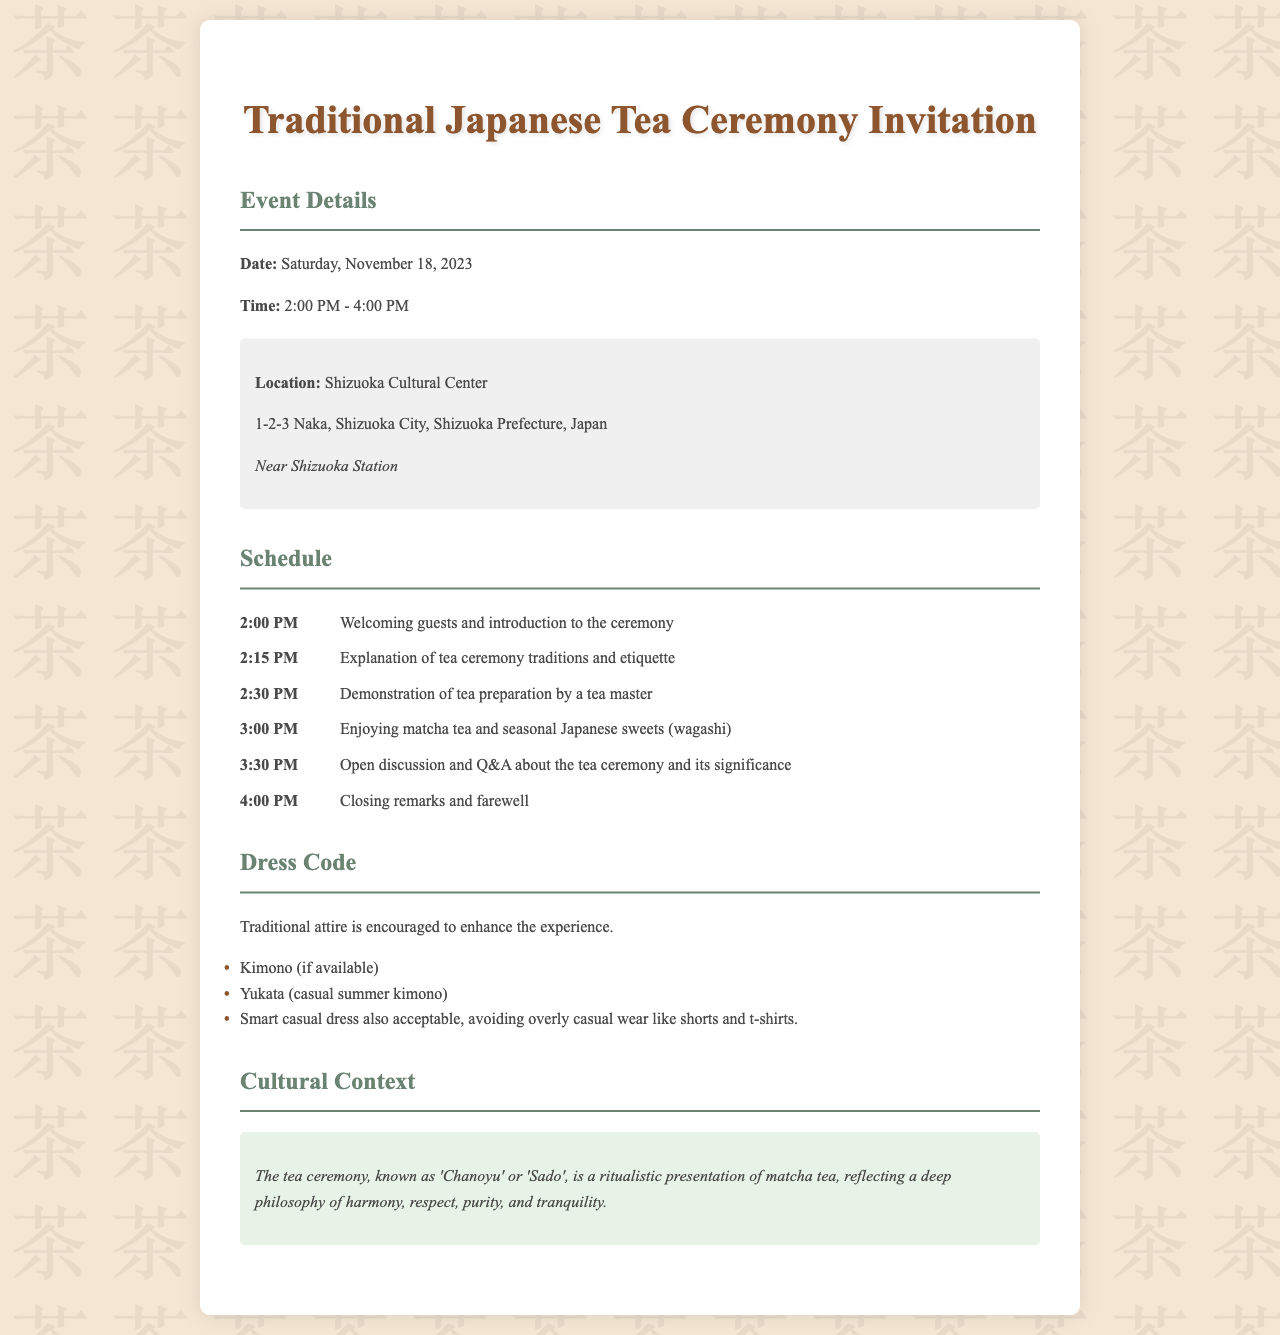What is the date of the tea ceremony? The date is prominently mentioned in the event details section of the document.
Answer: Saturday, November 18, 2023 What time does the tea ceremony start? The starting time is specified in the event details section under time.
Answer: 2:00 PM Where is the tea ceremony held? The location is provided in the event details section with the address specified.
Answer: Shizuoka Cultural Center What is the last activity in the schedule? The last item in the schedule describes the final remarks and is located at the end of the schedule section.
Answer: Closing remarks and farewell What is the dress code for the event? The dress code section specifies the attire encouraged for participants.
Answer: Traditional attire is encouraged What are the types of attire mentioned in the dress code? The dress code section lists specific types of attire participants can wear.
Answer: Kimono, Yukata, Smart casual Why is traditional attire encouraged? The dress code section suggests traditional attire enhances the experience of the tea ceremony.
Answer: To enhance the experience What does 'Chanoyu' refer to? The cultural context section defines 'Chanoyu' in relation to the tea ceremony, explaining its significance.
Answer: Ritualistic presentation of matcha tea What is served during the tea ceremony? The schedule mentions what guests will enjoy during the event, highlighting specific items.
Answer: Matcha tea and seasonal Japanese sweets (wagashi) 